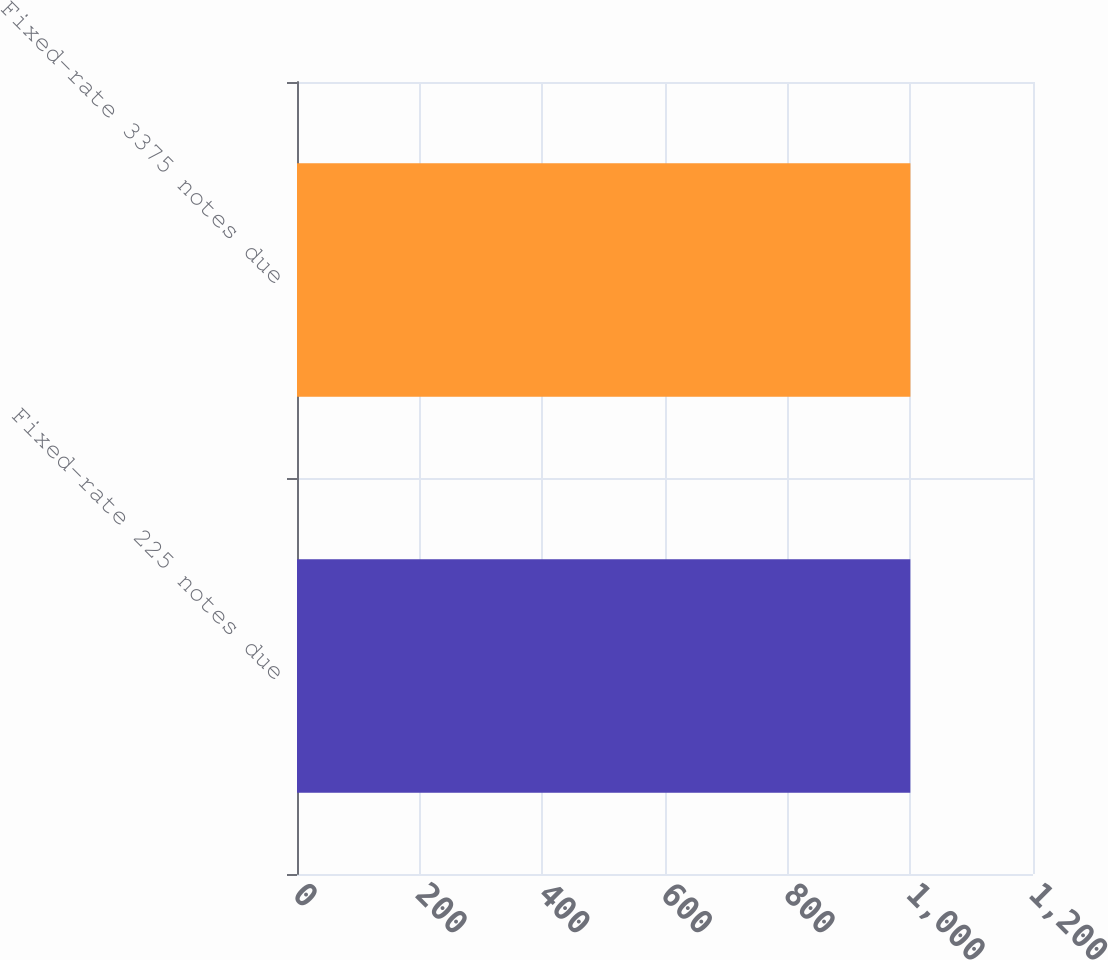Convert chart to OTSL. <chart><loc_0><loc_0><loc_500><loc_500><bar_chart><fcel>Fixed-rate 225 notes due<fcel>Fixed-rate 3375 notes due<nl><fcel>1000<fcel>1000.1<nl></chart> 